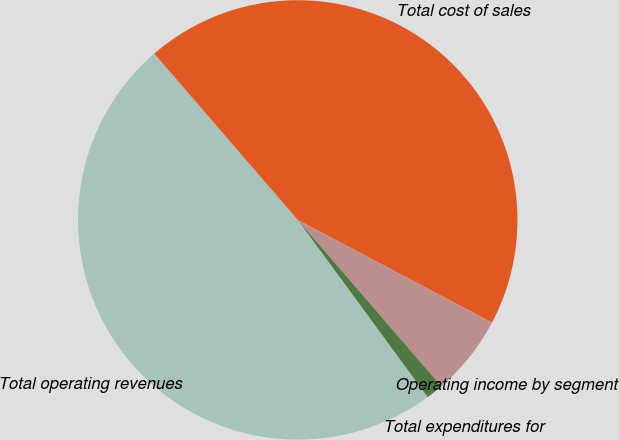<chart> <loc_0><loc_0><loc_500><loc_500><pie_chart><fcel>Total operating revenues<fcel>Total cost of sales<fcel>Operating income by segment<fcel>Total expenditures for<nl><fcel>48.74%<fcel>44.07%<fcel>5.93%<fcel>1.26%<nl></chart> 